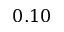<formula> <loc_0><loc_0><loc_500><loc_500>0 . 1 0</formula> 